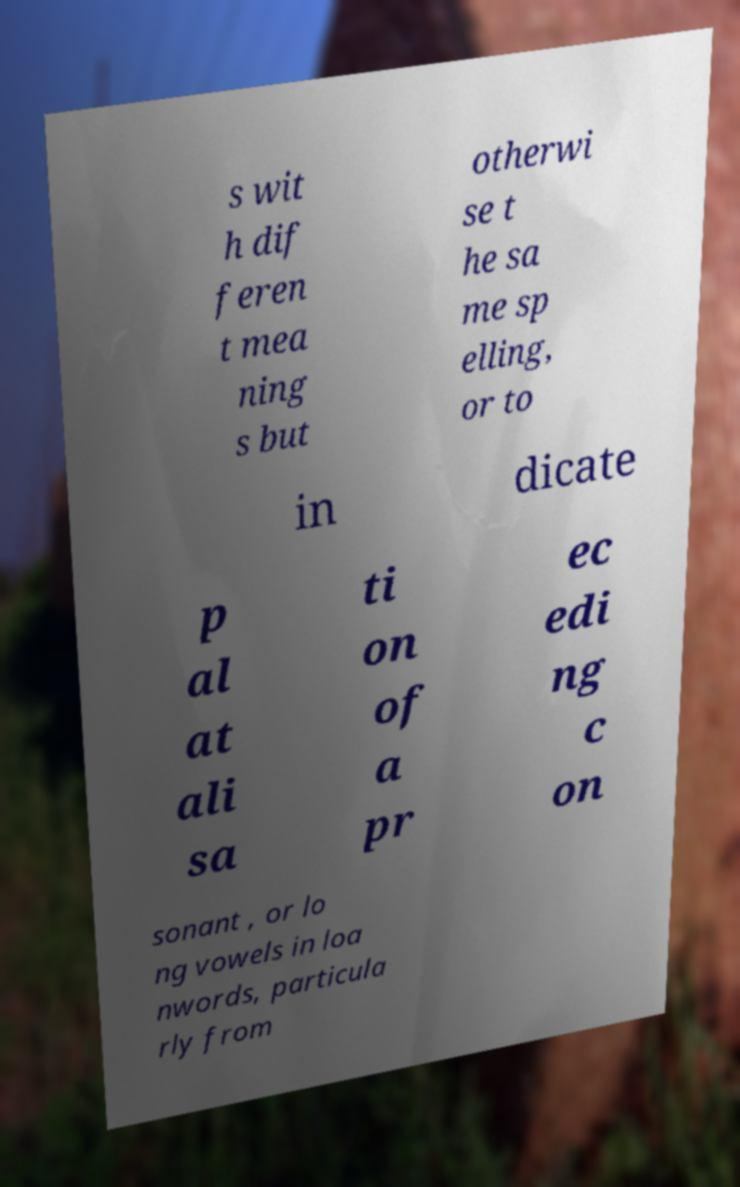Could you assist in decoding the text presented in this image and type it out clearly? s wit h dif feren t mea ning s but otherwi se t he sa me sp elling, or to in dicate p al at ali sa ti on of a pr ec edi ng c on sonant , or lo ng vowels in loa nwords, particula rly from 